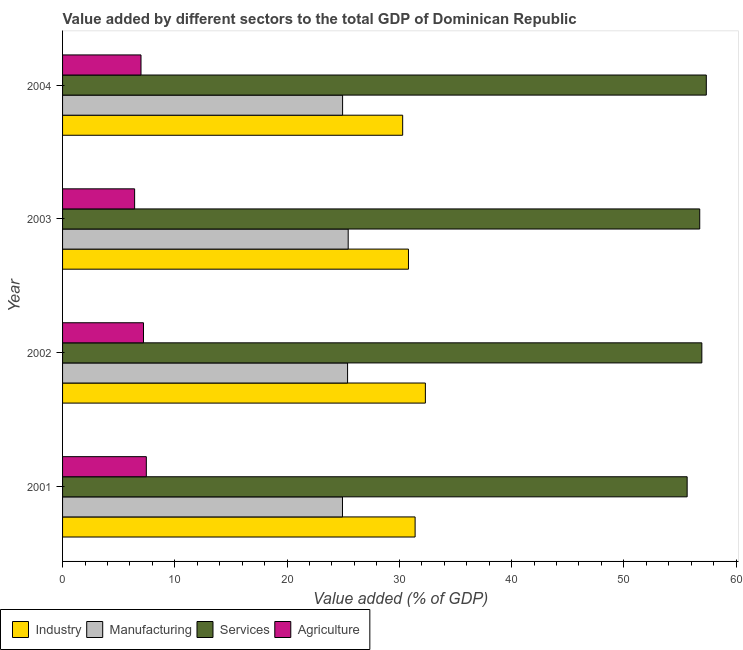How many different coloured bars are there?
Your response must be concise. 4. How many groups of bars are there?
Offer a very short reply. 4. Are the number of bars on each tick of the Y-axis equal?
Offer a terse response. Yes. How many bars are there on the 1st tick from the top?
Ensure brevity in your answer.  4. What is the label of the 2nd group of bars from the top?
Give a very brief answer. 2003. In how many cases, is the number of bars for a given year not equal to the number of legend labels?
Provide a short and direct response. 0. What is the value added by agricultural sector in 2002?
Keep it short and to the point. 7.21. Across all years, what is the maximum value added by manufacturing sector?
Your answer should be compact. 25.45. Across all years, what is the minimum value added by manufacturing sector?
Your response must be concise. 24.94. In which year was the value added by agricultural sector maximum?
Provide a short and direct response. 2001. What is the total value added by manufacturing sector in the graph?
Your answer should be compact. 100.72. What is the difference between the value added by services sector in 2001 and that in 2002?
Offer a terse response. -1.31. What is the difference between the value added by manufacturing sector in 2004 and the value added by industrial sector in 2001?
Offer a terse response. -6.46. What is the average value added by agricultural sector per year?
Your answer should be very brief. 7.02. In the year 2003, what is the difference between the value added by manufacturing sector and value added by services sector?
Ensure brevity in your answer.  -31.32. Is the value added by services sector in 2002 less than that in 2003?
Your answer should be very brief. No. Is the difference between the value added by industrial sector in 2001 and 2002 greater than the difference between the value added by manufacturing sector in 2001 and 2002?
Keep it short and to the point. No. What is the difference between the highest and the second highest value added by industrial sector?
Your response must be concise. 0.92. What is the difference between the highest and the lowest value added by services sector?
Your response must be concise. 1.71. In how many years, is the value added by industrial sector greater than the average value added by industrial sector taken over all years?
Provide a succinct answer. 2. What does the 2nd bar from the top in 2004 represents?
Provide a succinct answer. Services. What does the 2nd bar from the bottom in 2002 represents?
Provide a succinct answer. Manufacturing. How many years are there in the graph?
Offer a very short reply. 4. What is the difference between two consecutive major ticks on the X-axis?
Your response must be concise. 10. Are the values on the major ticks of X-axis written in scientific E-notation?
Offer a very short reply. No. How many legend labels are there?
Your answer should be compact. 4. How are the legend labels stacked?
Ensure brevity in your answer.  Horizontal. What is the title of the graph?
Your answer should be very brief. Value added by different sectors to the total GDP of Dominican Republic. What is the label or title of the X-axis?
Make the answer very short. Value added (% of GDP). What is the label or title of the Y-axis?
Your response must be concise. Year. What is the Value added (% of GDP) of Industry in 2001?
Offer a very short reply. 31.41. What is the Value added (% of GDP) of Manufacturing in 2001?
Make the answer very short. 24.94. What is the Value added (% of GDP) in Services in 2001?
Give a very brief answer. 55.64. What is the Value added (% of GDP) of Agriculture in 2001?
Keep it short and to the point. 7.46. What is the Value added (% of GDP) of Industry in 2002?
Provide a short and direct response. 32.32. What is the Value added (% of GDP) of Manufacturing in 2002?
Provide a short and direct response. 25.39. What is the Value added (% of GDP) in Services in 2002?
Offer a very short reply. 56.95. What is the Value added (% of GDP) of Agriculture in 2002?
Keep it short and to the point. 7.21. What is the Value added (% of GDP) of Industry in 2003?
Provide a succinct answer. 30.82. What is the Value added (% of GDP) of Manufacturing in 2003?
Give a very brief answer. 25.45. What is the Value added (% of GDP) of Services in 2003?
Your answer should be very brief. 56.76. What is the Value added (% of GDP) of Agriculture in 2003?
Provide a succinct answer. 6.42. What is the Value added (% of GDP) in Industry in 2004?
Keep it short and to the point. 30.3. What is the Value added (% of GDP) of Manufacturing in 2004?
Offer a terse response. 24.95. What is the Value added (% of GDP) in Services in 2004?
Offer a terse response. 57.35. What is the Value added (% of GDP) in Agriculture in 2004?
Offer a very short reply. 6.99. Across all years, what is the maximum Value added (% of GDP) of Industry?
Your answer should be compact. 32.32. Across all years, what is the maximum Value added (% of GDP) in Manufacturing?
Keep it short and to the point. 25.45. Across all years, what is the maximum Value added (% of GDP) in Services?
Provide a short and direct response. 57.35. Across all years, what is the maximum Value added (% of GDP) in Agriculture?
Your response must be concise. 7.46. Across all years, what is the minimum Value added (% of GDP) of Industry?
Keep it short and to the point. 30.3. Across all years, what is the minimum Value added (% of GDP) in Manufacturing?
Provide a short and direct response. 24.94. Across all years, what is the minimum Value added (% of GDP) in Services?
Your answer should be compact. 55.64. Across all years, what is the minimum Value added (% of GDP) in Agriculture?
Provide a succinct answer. 6.42. What is the total Value added (% of GDP) in Industry in the graph?
Keep it short and to the point. 124.85. What is the total Value added (% of GDP) of Manufacturing in the graph?
Provide a short and direct response. 100.72. What is the total Value added (% of GDP) in Services in the graph?
Offer a very short reply. 226.71. What is the total Value added (% of GDP) of Agriculture in the graph?
Keep it short and to the point. 28.08. What is the difference between the Value added (% of GDP) of Industry in 2001 and that in 2002?
Provide a succinct answer. -0.91. What is the difference between the Value added (% of GDP) in Manufacturing in 2001 and that in 2002?
Provide a succinct answer. -0.45. What is the difference between the Value added (% of GDP) in Services in 2001 and that in 2002?
Your response must be concise. -1.31. What is the difference between the Value added (% of GDP) in Agriculture in 2001 and that in 2002?
Keep it short and to the point. 0.25. What is the difference between the Value added (% of GDP) of Industry in 2001 and that in 2003?
Offer a very short reply. 0.59. What is the difference between the Value added (% of GDP) in Manufacturing in 2001 and that in 2003?
Provide a short and direct response. -0.51. What is the difference between the Value added (% of GDP) in Services in 2001 and that in 2003?
Offer a terse response. -1.12. What is the difference between the Value added (% of GDP) of Agriculture in 2001 and that in 2003?
Offer a very short reply. 1.04. What is the difference between the Value added (% of GDP) of Industry in 2001 and that in 2004?
Ensure brevity in your answer.  1.11. What is the difference between the Value added (% of GDP) of Manufacturing in 2001 and that in 2004?
Your response must be concise. -0.01. What is the difference between the Value added (% of GDP) in Services in 2001 and that in 2004?
Ensure brevity in your answer.  -1.71. What is the difference between the Value added (% of GDP) in Agriculture in 2001 and that in 2004?
Your answer should be compact. 0.47. What is the difference between the Value added (% of GDP) in Industry in 2002 and that in 2003?
Give a very brief answer. 1.51. What is the difference between the Value added (% of GDP) of Manufacturing in 2002 and that in 2003?
Your response must be concise. -0.05. What is the difference between the Value added (% of GDP) in Services in 2002 and that in 2003?
Make the answer very short. 0.19. What is the difference between the Value added (% of GDP) of Agriculture in 2002 and that in 2003?
Provide a succinct answer. 0.79. What is the difference between the Value added (% of GDP) of Industry in 2002 and that in 2004?
Offer a very short reply. 2.02. What is the difference between the Value added (% of GDP) in Manufacturing in 2002 and that in 2004?
Offer a terse response. 0.44. What is the difference between the Value added (% of GDP) of Services in 2002 and that in 2004?
Your response must be concise. -0.4. What is the difference between the Value added (% of GDP) of Agriculture in 2002 and that in 2004?
Your answer should be very brief. 0.22. What is the difference between the Value added (% of GDP) of Industry in 2003 and that in 2004?
Provide a succinct answer. 0.52. What is the difference between the Value added (% of GDP) of Manufacturing in 2003 and that in 2004?
Offer a terse response. 0.5. What is the difference between the Value added (% of GDP) in Services in 2003 and that in 2004?
Keep it short and to the point. -0.59. What is the difference between the Value added (% of GDP) in Agriculture in 2003 and that in 2004?
Provide a short and direct response. -0.57. What is the difference between the Value added (% of GDP) of Industry in 2001 and the Value added (% of GDP) of Manufacturing in 2002?
Offer a very short reply. 6.02. What is the difference between the Value added (% of GDP) of Industry in 2001 and the Value added (% of GDP) of Services in 2002?
Your response must be concise. -25.54. What is the difference between the Value added (% of GDP) of Industry in 2001 and the Value added (% of GDP) of Agriculture in 2002?
Provide a succinct answer. 24.2. What is the difference between the Value added (% of GDP) of Manufacturing in 2001 and the Value added (% of GDP) of Services in 2002?
Ensure brevity in your answer.  -32.02. What is the difference between the Value added (% of GDP) of Manufacturing in 2001 and the Value added (% of GDP) of Agriculture in 2002?
Offer a terse response. 17.73. What is the difference between the Value added (% of GDP) in Services in 2001 and the Value added (% of GDP) in Agriculture in 2002?
Provide a succinct answer. 48.43. What is the difference between the Value added (% of GDP) in Industry in 2001 and the Value added (% of GDP) in Manufacturing in 2003?
Provide a succinct answer. 5.96. What is the difference between the Value added (% of GDP) of Industry in 2001 and the Value added (% of GDP) of Services in 2003?
Provide a succinct answer. -25.36. What is the difference between the Value added (% of GDP) of Industry in 2001 and the Value added (% of GDP) of Agriculture in 2003?
Your answer should be compact. 24.99. What is the difference between the Value added (% of GDP) of Manufacturing in 2001 and the Value added (% of GDP) of Services in 2003?
Give a very brief answer. -31.83. What is the difference between the Value added (% of GDP) of Manufacturing in 2001 and the Value added (% of GDP) of Agriculture in 2003?
Ensure brevity in your answer.  18.52. What is the difference between the Value added (% of GDP) of Services in 2001 and the Value added (% of GDP) of Agriculture in 2003?
Ensure brevity in your answer.  49.23. What is the difference between the Value added (% of GDP) of Industry in 2001 and the Value added (% of GDP) of Manufacturing in 2004?
Provide a short and direct response. 6.46. What is the difference between the Value added (% of GDP) of Industry in 2001 and the Value added (% of GDP) of Services in 2004?
Offer a terse response. -25.94. What is the difference between the Value added (% of GDP) of Industry in 2001 and the Value added (% of GDP) of Agriculture in 2004?
Keep it short and to the point. 24.42. What is the difference between the Value added (% of GDP) of Manufacturing in 2001 and the Value added (% of GDP) of Services in 2004?
Ensure brevity in your answer.  -32.41. What is the difference between the Value added (% of GDP) of Manufacturing in 2001 and the Value added (% of GDP) of Agriculture in 2004?
Offer a terse response. 17.95. What is the difference between the Value added (% of GDP) of Services in 2001 and the Value added (% of GDP) of Agriculture in 2004?
Ensure brevity in your answer.  48.66. What is the difference between the Value added (% of GDP) of Industry in 2002 and the Value added (% of GDP) of Manufacturing in 2003?
Offer a very short reply. 6.88. What is the difference between the Value added (% of GDP) in Industry in 2002 and the Value added (% of GDP) in Services in 2003?
Keep it short and to the point. -24.44. What is the difference between the Value added (% of GDP) of Industry in 2002 and the Value added (% of GDP) of Agriculture in 2003?
Make the answer very short. 25.9. What is the difference between the Value added (% of GDP) in Manufacturing in 2002 and the Value added (% of GDP) in Services in 2003?
Provide a short and direct response. -31.37. What is the difference between the Value added (% of GDP) of Manufacturing in 2002 and the Value added (% of GDP) of Agriculture in 2003?
Offer a very short reply. 18.97. What is the difference between the Value added (% of GDP) in Services in 2002 and the Value added (% of GDP) in Agriculture in 2003?
Give a very brief answer. 50.53. What is the difference between the Value added (% of GDP) in Industry in 2002 and the Value added (% of GDP) in Manufacturing in 2004?
Offer a terse response. 7.38. What is the difference between the Value added (% of GDP) in Industry in 2002 and the Value added (% of GDP) in Services in 2004?
Offer a terse response. -25.03. What is the difference between the Value added (% of GDP) of Industry in 2002 and the Value added (% of GDP) of Agriculture in 2004?
Keep it short and to the point. 25.34. What is the difference between the Value added (% of GDP) in Manufacturing in 2002 and the Value added (% of GDP) in Services in 2004?
Provide a short and direct response. -31.96. What is the difference between the Value added (% of GDP) of Manufacturing in 2002 and the Value added (% of GDP) of Agriculture in 2004?
Provide a succinct answer. 18.4. What is the difference between the Value added (% of GDP) of Services in 2002 and the Value added (% of GDP) of Agriculture in 2004?
Your answer should be very brief. 49.97. What is the difference between the Value added (% of GDP) in Industry in 2003 and the Value added (% of GDP) in Manufacturing in 2004?
Make the answer very short. 5.87. What is the difference between the Value added (% of GDP) of Industry in 2003 and the Value added (% of GDP) of Services in 2004?
Provide a short and direct response. -26.53. What is the difference between the Value added (% of GDP) of Industry in 2003 and the Value added (% of GDP) of Agriculture in 2004?
Keep it short and to the point. 23.83. What is the difference between the Value added (% of GDP) of Manufacturing in 2003 and the Value added (% of GDP) of Services in 2004?
Provide a succinct answer. -31.91. What is the difference between the Value added (% of GDP) in Manufacturing in 2003 and the Value added (% of GDP) in Agriculture in 2004?
Your answer should be compact. 18.46. What is the difference between the Value added (% of GDP) of Services in 2003 and the Value added (% of GDP) of Agriculture in 2004?
Give a very brief answer. 49.78. What is the average Value added (% of GDP) of Industry per year?
Make the answer very short. 31.21. What is the average Value added (% of GDP) of Manufacturing per year?
Your response must be concise. 25.18. What is the average Value added (% of GDP) of Services per year?
Offer a very short reply. 56.68. What is the average Value added (% of GDP) of Agriculture per year?
Give a very brief answer. 7.02. In the year 2001, what is the difference between the Value added (% of GDP) of Industry and Value added (% of GDP) of Manufacturing?
Provide a short and direct response. 6.47. In the year 2001, what is the difference between the Value added (% of GDP) of Industry and Value added (% of GDP) of Services?
Offer a very short reply. -24.24. In the year 2001, what is the difference between the Value added (% of GDP) in Industry and Value added (% of GDP) in Agriculture?
Keep it short and to the point. 23.95. In the year 2001, what is the difference between the Value added (% of GDP) of Manufacturing and Value added (% of GDP) of Services?
Your answer should be compact. -30.71. In the year 2001, what is the difference between the Value added (% of GDP) of Manufacturing and Value added (% of GDP) of Agriculture?
Ensure brevity in your answer.  17.48. In the year 2001, what is the difference between the Value added (% of GDP) of Services and Value added (% of GDP) of Agriculture?
Keep it short and to the point. 48.18. In the year 2002, what is the difference between the Value added (% of GDP) of Industry and Value added (% of GDP) of Manufacturing?
Your response must be concise. 6.93. In the year 2002, what is the difference between the Value added (% of GDP) of Industry and Value added (% of GDP) of Services?
Keep it short and to the point. -24.63. In the year 2002, what is the difference between the Value added (% of GDP) of Industry and Value added (% of GDP) of Agriculture?
Make the answer very short. 25.11. In the year 2002, what is the difference between the Value added (% of GDP) in Manufacturing and Value added (% of GDP) in Services?
Your answer should be very brief. -31.56. In the year 2002, what is the difference between the Value added (% of GDP) in Manufacturing and Value added (% of GDP) in Agriculture?
Offer a very short reply. 18.18. In the year 2002, what is the difference between the Value added (% of GDP) of Services and Value added (% of GDP) of Agriculture?
Your answer should be compact. 49.74. In the year 2003, what is the difference between the Value added (% of GDP) in Industry and Value added (% of GDP) in Manufacturing?
Give a very brief answer. 5.37. In the year 2003, what is the difference between the Value added (% of GDP) of Industry and Value added (% of GDP) of Services?
Make the answer very short. -25.95. In the year 2003, what is the difference between the Value added (% of GDP) of Industry and Value added (% of GDP) of Agriculture?
Provide a succinct answer. 24.4. In the year 2003, what is the difference between the Value added (% of GDP) of Manufacturing and Value added (% of GDP) of Services?
Ensure brevity in your answer.  -31.32. In the year 2003, what is the difference between the Value added (% of GDP) in Manufacturing and Value added (% of GDP) in Agriculture?
Your answer should be very brief. 19.03. In the year 2003, what is the difference between the Value added (% of GDP) of Services and Value added (% of GDP) of Agriculture?
Ensure brevity in your answer.  50.35. In the year 2004, what is the difference between the Value added (% of GDP) of Industry and Value added (% of GDP) of Manufacturing?
Offer a terse response. 5.35. In the year 2004, what is the difference between the Value added (% of GDP) in Industry and Value added (% of GDP) in Services?
Offer a terse response. -27.05. In the year 2004, what is the difference between the Value added (% of GDP) of Industry and Value added (% of GDP) of Agriculture?
Your answer should be very brief. 23.31. In the year 2004, what is the difference between the Value added (% of GDP) in Manufacturing and Value added (% of GDP) in Services?
Give a very brief answer. -32.4. In the year 2004, what is the difference between the Value added (% of GDP) of Manufacturing and Value added (% of GDP) of Agriculture?
Keep it short and to the point. 17.96. In the year 2004, what is the difference between the Value added (% of GDP) in Services and Value added (% of GDP) in Agriculture?
Make the answer very short. 50.36. What is the ratio of the Value added (% of GDP) in Industry in 2001 to that in 2002?
Provide a short and direct response. 0.97. What is the ratio of the Value added (% of GDP) in Manufacturing in 2001 to that in 2002?
Provide a succinct answer. 0.98. What is the ratio of the Value added (% of GDP) in Agriculture in 2001 to that in 2002?
Provide a short and direct response. 1.03. What is the ratio of the Value added (% of GDP) in Industry in 2001 to that in 2003?
Give a very brief answer. 1.02. What is the ratio of the Value added (% of GDP) of Manufacturing in 2001 to that in 2003?
Offer a very short reply. 0.98. What is the ratio of the Value added (% of GDP) in Services in 2001 to that in 2003?
Your answer should be compact. 0.98. What is the ratio of the Value added (% of GDP) in Agriculture in 2001 to that in 2003?
Your response must be concise. 1.16. What is the ratio of the Value added (% of GDP) of Industry in 2001 to that in 2004?
Make the answer very short. 1.04. What is the ratio of the Value added (% of GDP) of Manufacturing in 2001 to that in 2004?
Provide a short and direct response. 1. What is the ratio of the Value added (% of GDP) in Services in 2001 to that in 2004?
Offer a very short reply. 0.97. What is the ratio of the Value added (% of GDP) in Agriculture in 2001 to that in 2004?
Keep it short and to the point. 1.07. What is the ratio of the Value added (% of GDP) in Industry in 2002 to that in 2003?
Offer a terse response. 1.05. What is the ratio of the Value added (% of GDP) of Manufacturing in 2002 to that in 2003?
Make the answer very short. 1. What is the ratio of the Value added (% of GDP) in Services in 2002 to that in 2003?
Your answer should be very brief. 1. What is the ratio of the Value added (% of GDP) in Agriculture in 2002 to that in 2003?
Provide a short and direct response. 1.12. What is the ratio of the Value added (% of GDP) of Industry in 2002 to that in 2004?
Offer a terse response. 1.07. What is the ratio of the Value added (% of GDP) of Manufacturing in 2002 to that in 2004?
Ensure brevity in your answer.  1.02. What is the ratio of the Value added (% of GDP) of Agriculture in 2002 to that in 2004?
Give a very brief answer. 1.03. What is the ratio of the Value added (% of GDP) of Manufacturing in 2003 to that in 2004?
Keep it short and to the point. 1.02. What is the ratio of the Value added (% of GDP) of Services in 2003 to that in 2004?
Your response must be concise. 0.99. What is the ratio of the Value added (% of GDP) of Agriculture in 2003 to that in 2004?
Provide a succinct answer. 0.92. What is the difference between the highest and the second highest Value added (% of GDP) in Industry?
Your answer should be compact. 0.91. What is the difference between the highest and the second highest Value added (% of GDP) in Manufacturing?
Offer a very short reply. 0.05. What is the difference between the highest and the second highest Value added (% of GDP) in Services?
Offer a very short reply. 0.4. What is the difference between the highest and the second highest Value added (% of GDP) in Agriculture?
Your answer should be very brief. 0.25. What is the difference between the highest and the lowest Value added (% of GDP) of Industry?
Provide a succinct answer. 2.02. What is the difference between the highest and the lowest Value added (% of GDP) of Manufacturing?
Make the answer very short. 0.51. What is the difference between the highest and the lowest Value added (% of GDP) in Services?
Your answer should be compact. 1.71. What is the difference between the highest and the lowest Value added (% of GDP) in Agriculture?
Your answer should be very brief. 1.04. 